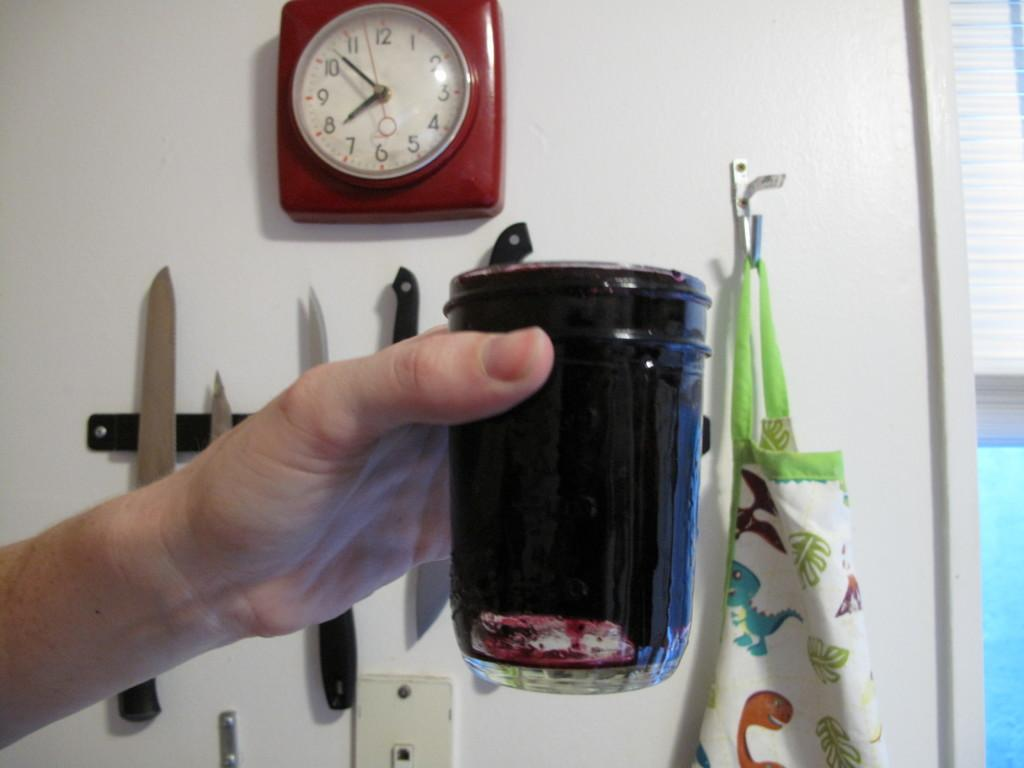<image>
Create a compact narrative representing the image presented. A clock reading 7:52 is behind a glass being held in a hand. 